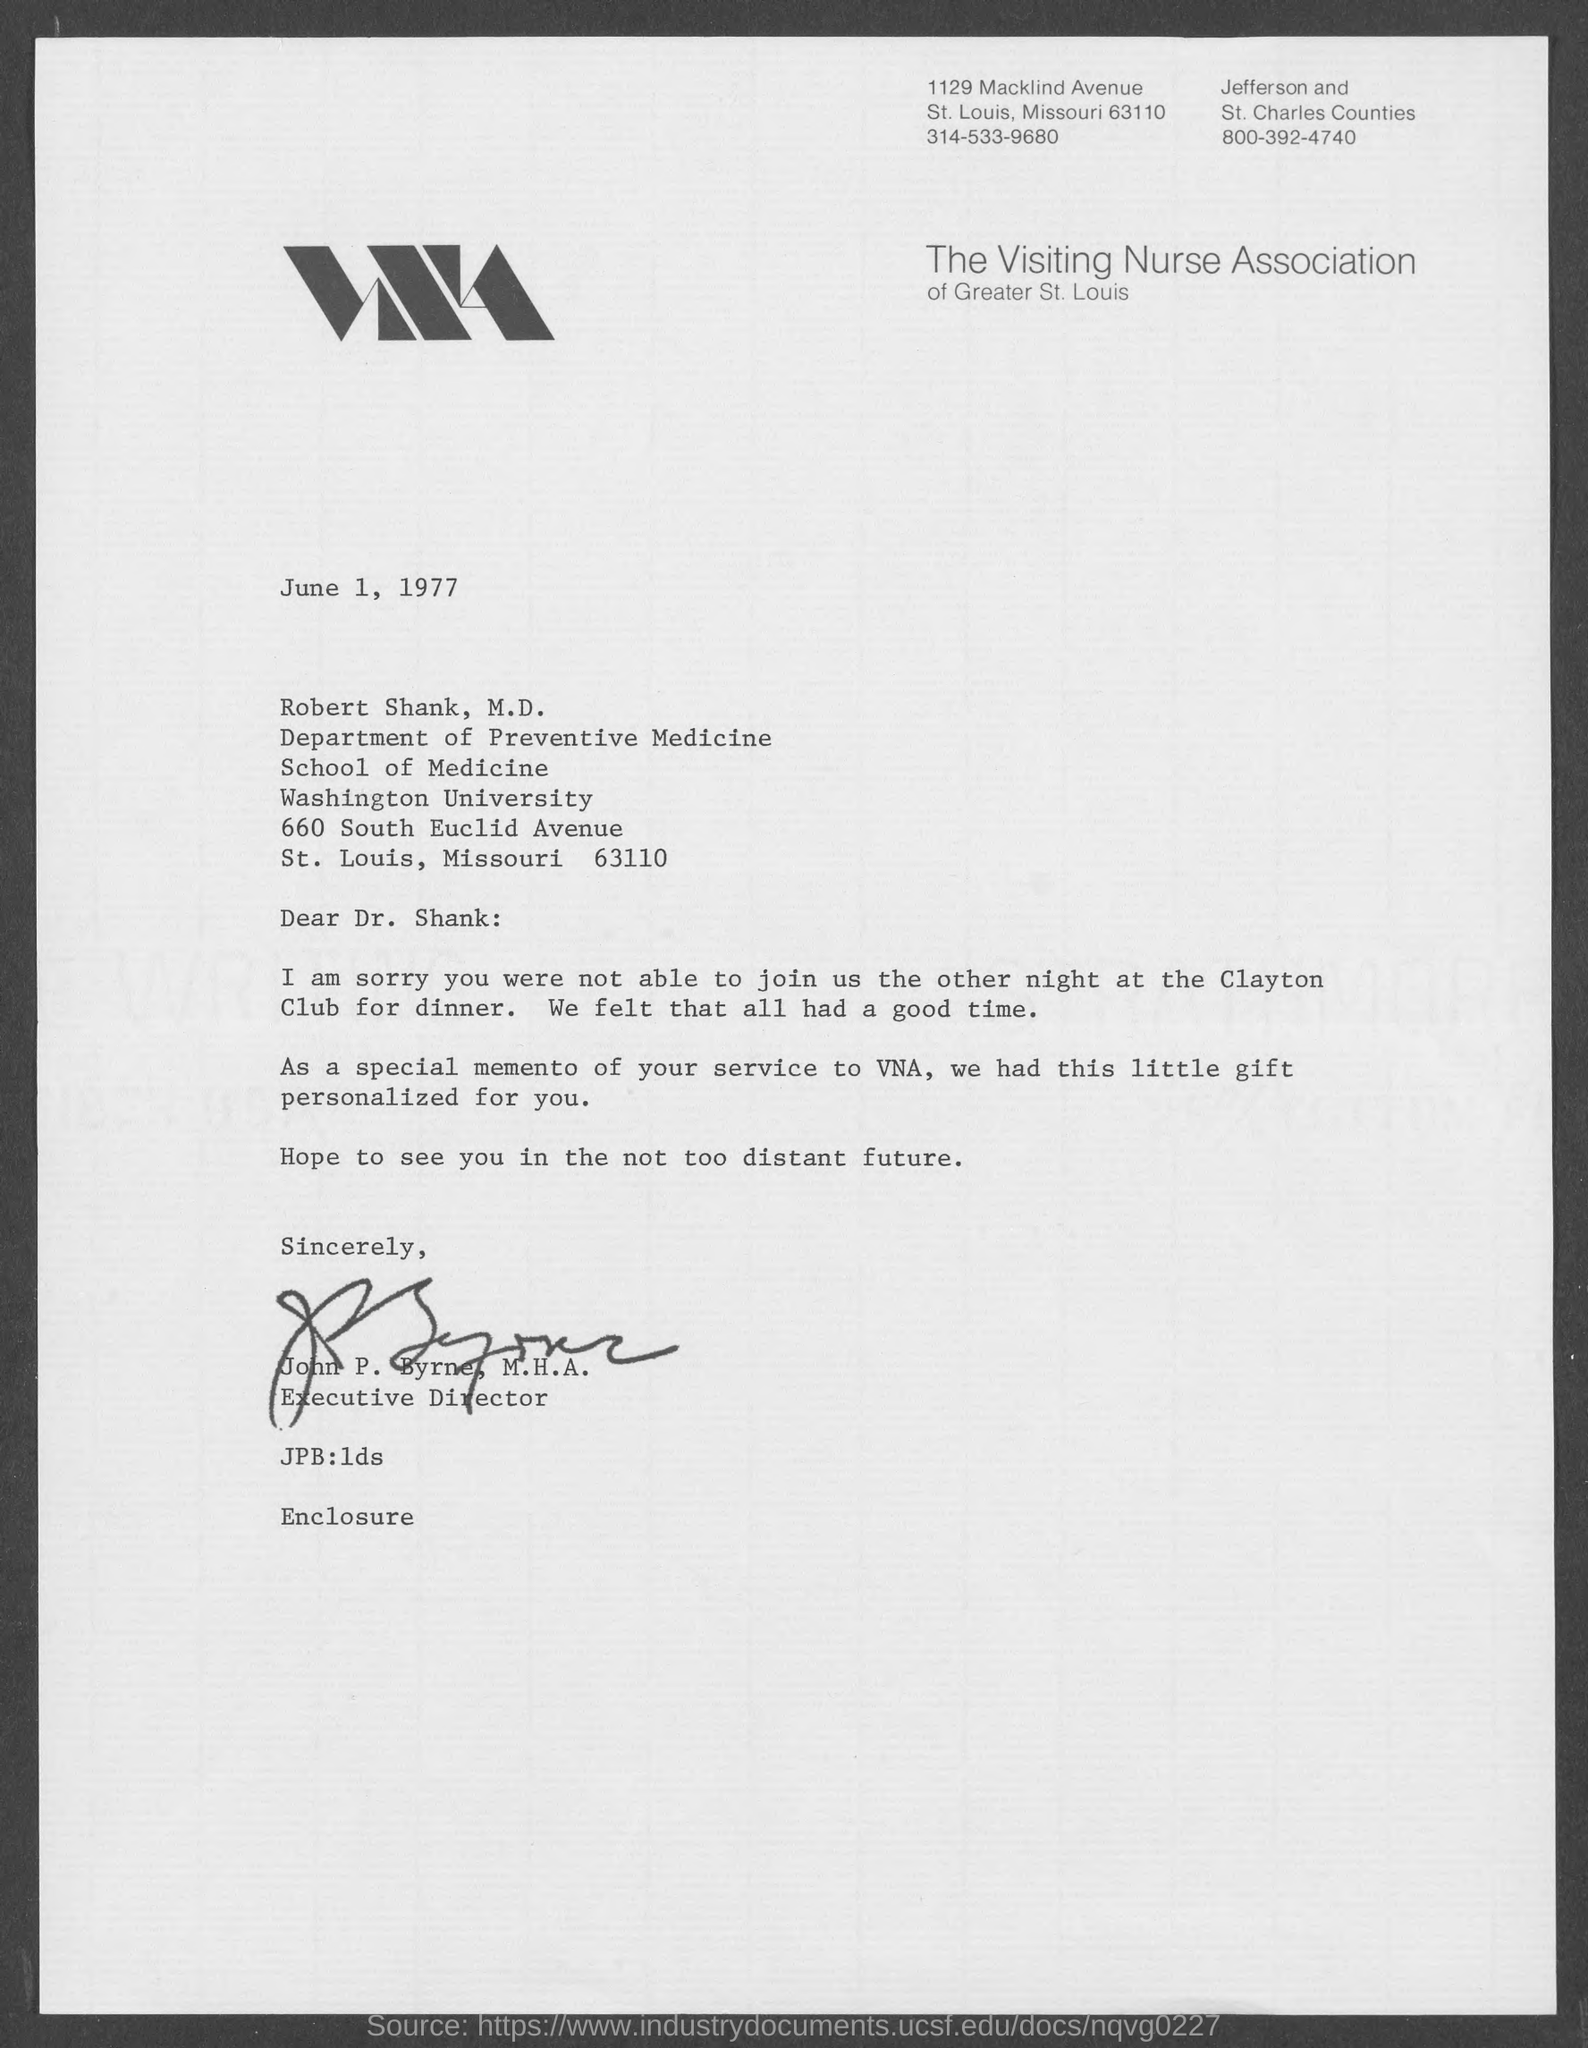Which Association is mentioned in the letterhead?
Offer a very short reply. The Visiting Nurse Association. What is the date mentioned in this letter?
Give a very brief answer. June 1, 1977. Who is the sender of this letter?
Your answer should be compact. John P. Byrne, M.H.A. What is the designation of John  P. Byrne, M.H.A.?
Provide a succinct answer. Executive Director. 